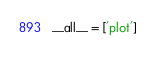<code> <loc_0><loc_0><loc_500><loc_500><_Python_>
__all__ = ['plot']</code> 